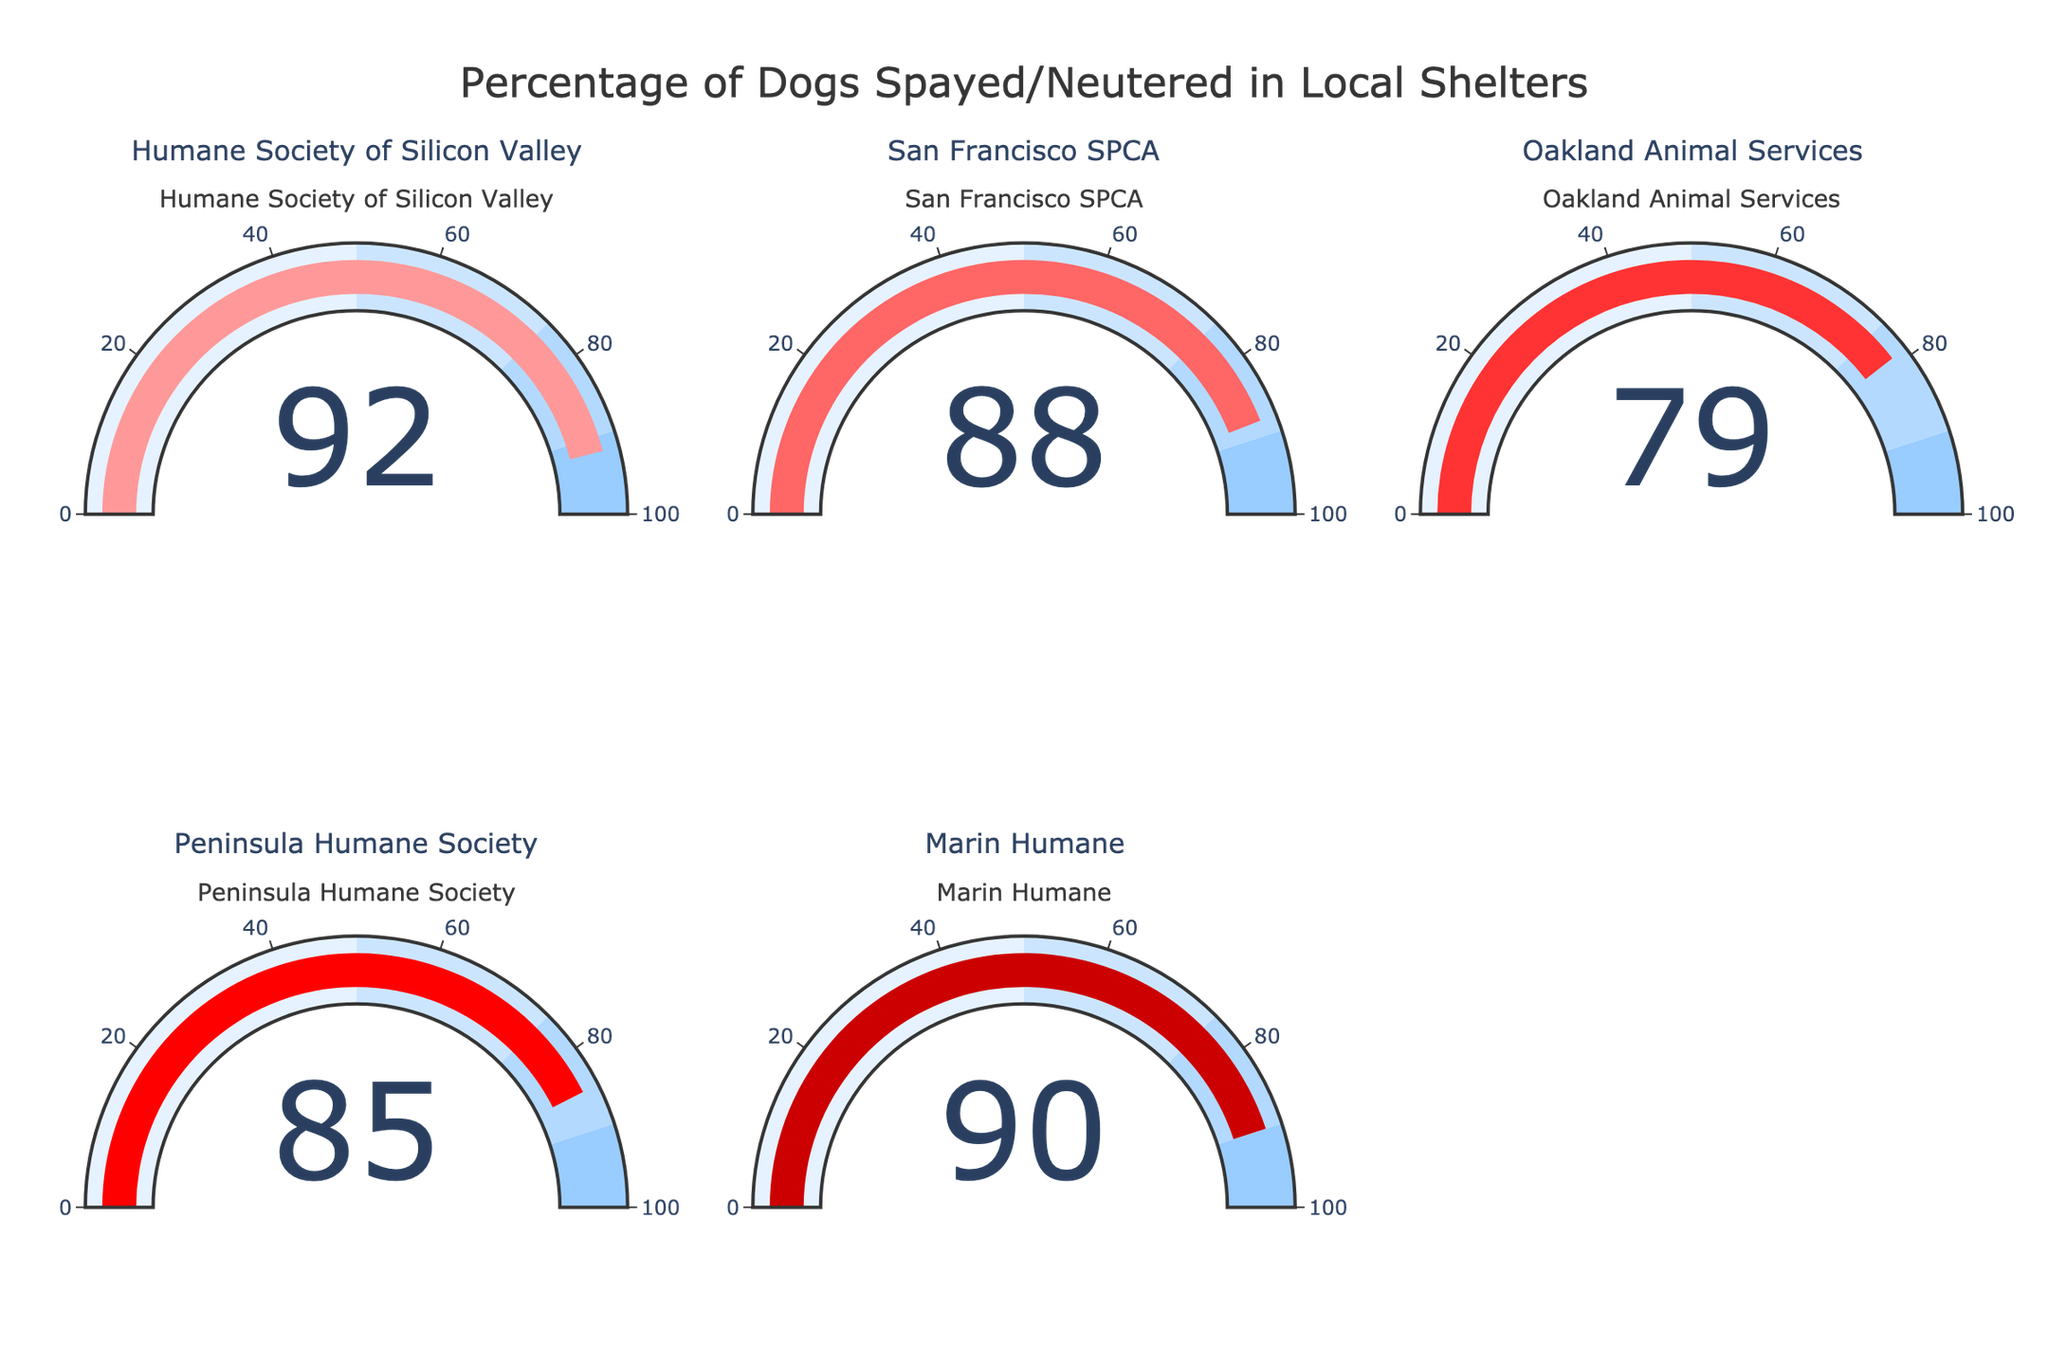What's the title of the figure? Look at the top of the figure where the main heading is displayed.
Answer: "Percentage of Dogs Spayed/Neutered in Local Shelters" How many local shelters are represented in the figure? Count the number of gauges displayed. Each gauge represents one local shelter.
Answer: 5 Which shelter has the highest percentage of spayed/neutered dogs? Examine each gauge value and identify the one with the highest percentage.
Answer: Humane Society of Silicon Valley Which shelter has a lower percentage of spayed/neutered dogs, San Francisco SPCA or Peninsula Humane Society? Compare the gauge value for San Francisco SPCA (88%) with Peninsula Humane Society (85%).
Answer: Peninsula Humane Society What's the average percentage of spayed/neutered dogs across all shelters? Sum the percentages of all shelters (92 + 88 + 79 + 85 + 90) and divide by 5. (92 + 88 + 79 + 85 + 90) / 5 = 434 / 5 = 86.8
Answer: 86.8 What's the difference in the percentage of spayed/neutered dogs between the shelter with the highest percentage and the shelter with the lowest percentage? Identify the highest percentage (92%) and the lowest percentage (79%). Subtract the lowest from the highest. 92 - 79 = 13
Answer: 13 Which shelters have a percentage of spayed/neutered dogs greater than 85%? Identify gauges with values above 85%. They are Humane Society of Silicon Valley (92%), San Francisco SPCA (88%), and Marin Humane (90%).
Answer: Humane Society of Silicon Valley, San Francisco SPCA, Marin Humane Are there any shelters with a percentage of spayed/neutered dogs between 80% and 90%? Check the gauges for values within the range 80% to 90%. San Francisco SPCA (88%), Peninsula Humane Society (85%), and Marin Humane (90%) fall within this range.
Answer: San Francisco SPCA, Peninsula Humane Society, Marin Humane What's the combined percentage of spayed/neutered dogs for Oakland Animal Services and Marin Humane? Add the percentages for Oakland Animal Services (79%) and Marin Humane (90%). 79 + 90 = 169
Answer: 169 